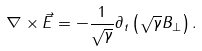Convert formula to latex. <formula><loc_0><loc_0><loc_500><loc_500>\nabla \times \vec { E } = - \frac { 1 } { \sqrt { \gamma } } \partial _ { t } \left ( \sqrt { \gamma } B _ { \perp } \right ) .</formula> 